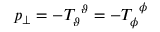Convert formula to latex. <formula><loc_0><loc_0><loc_500><loc_500>p _ { \perp } = - T _ { \vartheta } ^ { \vartheta } = - T _ { \phi } ^ { \phi }</formula> 